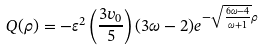<formula> <loc_0><loc_0><loc_500><loc_500>Q ( \rho ) = - \varepsilon ^ { 2 } \left ( \frac { 3 v _ { 0 } } { 5 } \right ) ( 3 \omega - 2 ) e ^ { - \sqrt { \frac { 6 \omega - 4 } { \omega + 1 } } \rho }</formula> 